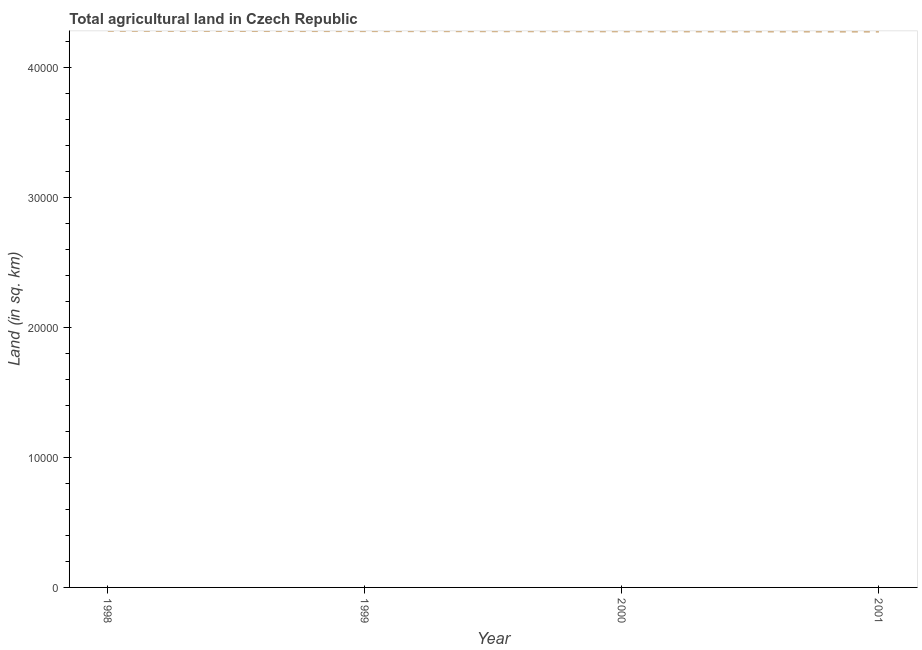What is the agricultural land in 2000?
Keep it short and to the point. 4.28e+04. Across all years, what is the maximum agricultural land?
Keep it short and to the point. 4.28e+04. Across all years, what is the minimum agricultural land?
Ensure brevity in your answer.  4.28e+04. In which year was the agricultural land maximum?
Offer a very short reply. 1998. What is the sum of the agricultural land?
Your response must be concise. 1.71e+05. What is the difference between the agricultural land in 1998 and 1999?
Your answer should be very brief. 20. What is the average agricultural land per year?
Ensure brevity in your answer.  4.28e+04. What is the median agricultural land?
Your answer should be very brief. 4.28e+04. Do a majority of the years between 2001 and 1999 (inclusive) have agricultural land greater than 24000 sq. km?
Provide a short and direct response. No. What is the ratio of the agricultural land in 1999 to that in 2001?
Give a very brief answer. 1. Is the agricultural land in 1999 less than that in 2000?
Offer a terse response. No. Is the difference between the agricultural land in 1999 and 2001 greater than the difference between any two years?
Make the answer very short. No. Is the sum of the agricultural land in 1998 and 2000 greater than the maximum agricultural land across all years?
Make the answer very short. Yes. What is the difference between the highest and the lowest agricultural land?
Provide a succinct answer. 60. In how many years, is the agricultural land greater than the average agricultural land taken over all years?
Offer a terse response. 2. How many lines are there?
Offer a very short reply. 1. What is the difference between two consecutive major ticks on the Y-axis?
Provide a succinct answer. 10000. Are the values on the major ticks of Y-axis written in scientific E-notation?
Ensure brevity in your answer.  No. Does the graph contain any zero values?
Offer a terse response. No. What is the title of the graph?
Make the answer very short. Total agricultural land in Czech Republic. What is the label or title of the X-axis?
Ensure brevity in your answer.  Year. What is the label or title of the Y-axis?
Provide a succinct answer. Land (in sq. km). What is the Land (in sq. km) in 1998?
Make the answer very short. 4.28e+04. What is the Land (in sq. km) of 1999?
Provide a short and direct response. 4.28e+04. What is the Land (in sq. km) in 2000?
Your answer should be compact. 4.28e+04. What is the Land (in sq. km) in 2001?
Make the answer very short. 4.28e+04. What is the difference between the Land (in sq. km) in 1998 and 2000?
Make the answer very short. 40. What is the difference between the Land (in sq. km) in 1999 and 2000?
Ensure brevity in your answer.  20. What is the difference between the Land (in sq. km) in 2000 and 2001?
Offer a terse response. 20. What is the ratio of the Land (in sq. km) in 1998 to that in 2000?
Offer a terse response. 1. What is the ratio of the Land (in sq. km) in 1998 to that in 2001?
Give a very brief answer. 1. What is the ratio of the Land (in sq. km) in 1999 to that in 2000?
Your response must be concise. 1. What is the ratio of the Land (in sq. km) in 1999 to that in 2001?
Ensure brevity in your answer.  1. 